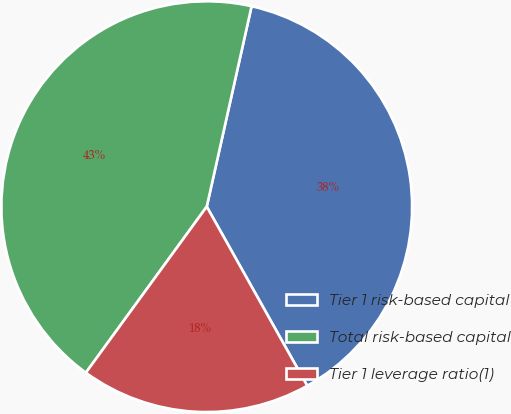Convert chart to OTSL. <chart><loc_0><loc_0><loc_500><loc_500><pie_chart><fcel>Tier 1 risk-based capital<fcel>Total risk-based capital<fcel>Tier 1 leverage ratio(1)<nl><fcel>38.36%<fcel>43.49%<fcel>18.15%<nl></chart> 